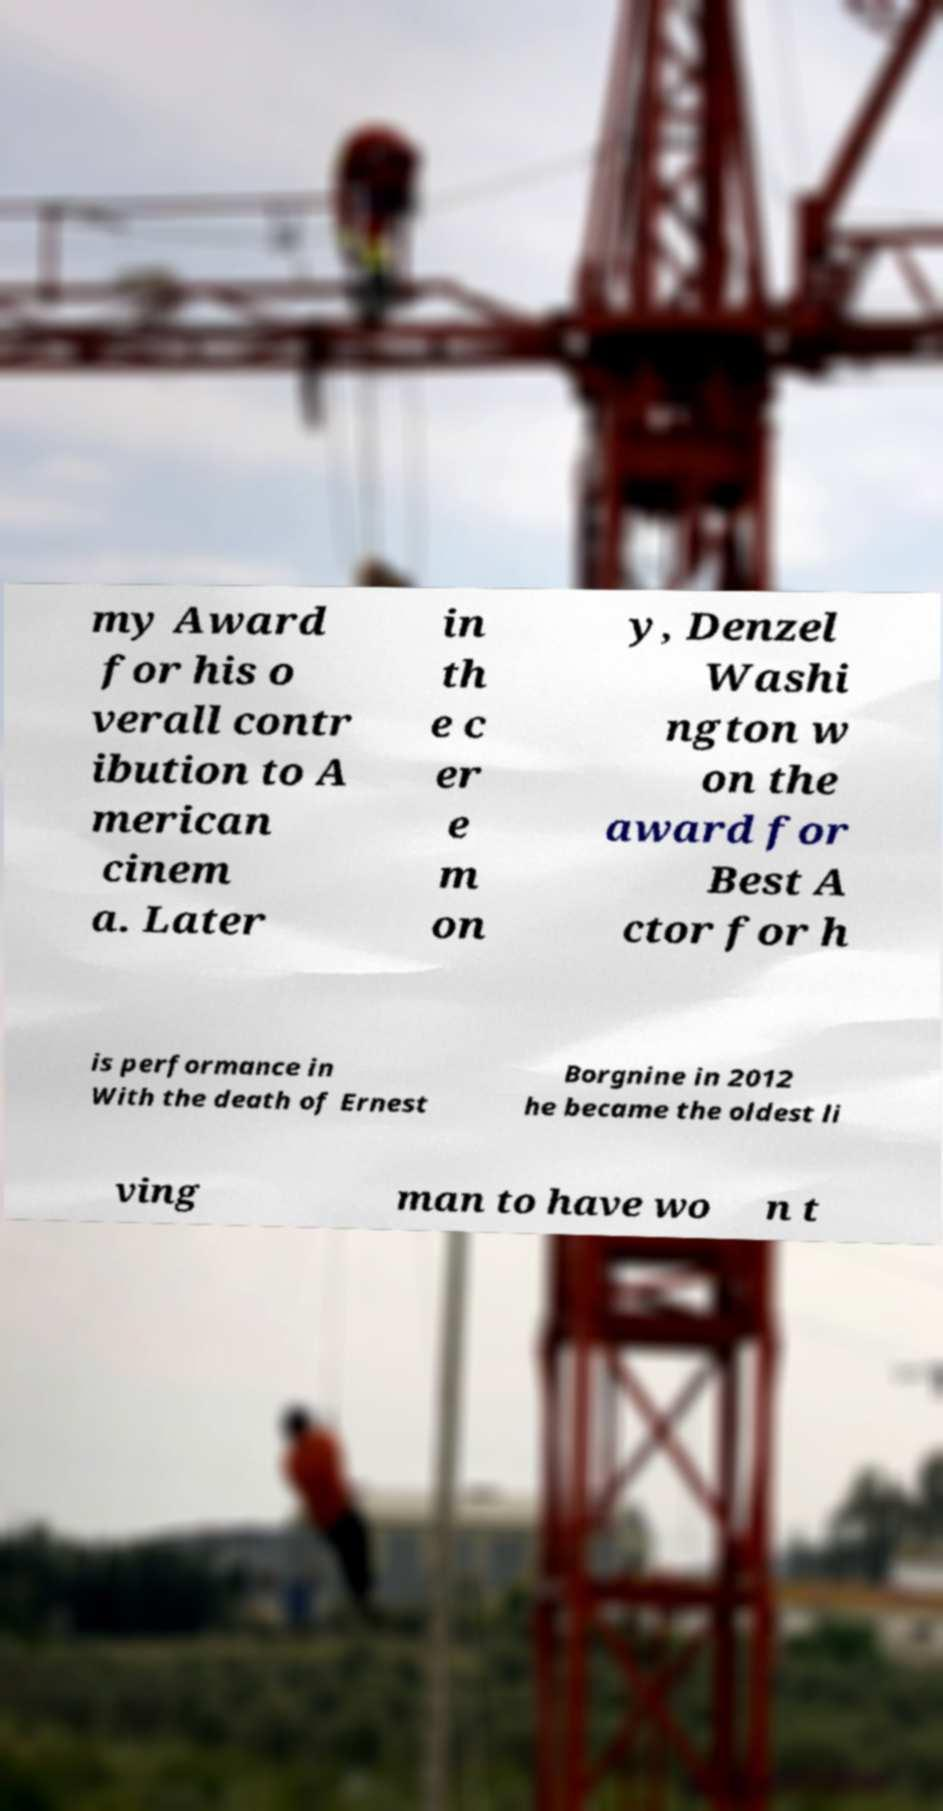Can you accurately transcribe the text from the provided image for me? my Award for his o verall contr ibution to A merican cinem a. Later in th e c er e m on y, Denzel Washi ngton w on the award for Best A ctor for h is performance in With the death of Ernest Borgnine in 2012 he became the oldest li ving man to have wo n t 